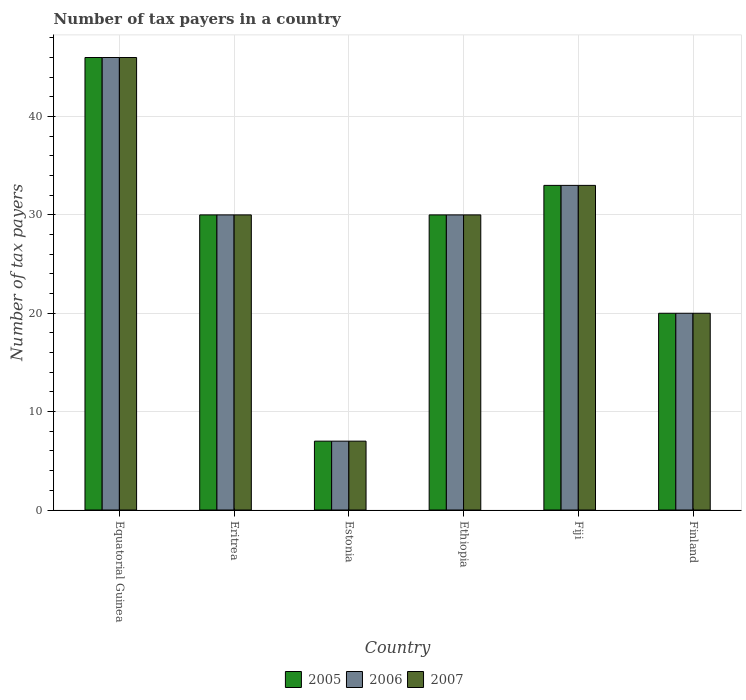How many bars are there on the 2nd tick from the left?
Provide a succinct answer. 3. How many bars are there on the 3rd tick from the right?
Your answer should be compact. 3. What is the label of the 4th group of bars from the left?
Offer a terse response. Ethiopia. In which country was the number of tax payers in in 2007 maximum?
Offer a very short reply. Equatorial Guinea. In which country was the number of tax payers in in 2007 minimum?
Make the answer very short. Estonia. What is the total number of tax payers in in 2005 in the graph?
Provide a succinct answer. 166. What is the difference between the number of tax payers in in 2005 in Eritrea and that in Estonia?
Make the answer very short. 23. What is the difference between the number of tax payers in in 2007 in Eritrea and the number of tax payers in in 2006 in Estonia?
Give a very brief answer. 23. What is the average number of tax payers in in 2007 per country?
Provide a short and direct response. 27.67. What is the difference between the number of tax payers in of/in 2005 and number of tax payers in of/in 2006 in Fiji?
Offer a very short reply. 0. Is the difference between the number of tax payers in in 2005 in Estonia and Fiji greater than the difference between the number of tax payers in in 2006 in Estonia and Fiji?
Provide a short and direct response. No. What is the difference between the highest and the lowest number of tax payers in in 2005?
Your answer should be very brief. 39. In how many countries, is the number of tax payers in in 2005 greater than the average number of tax payers in in 2005 taken over all countries?
Your answer should be compact. 4. How many bars are there?
Keep it short and to the point. 18. How many countries are there in the graph?
Your answer should be very brief. 6. What is the difference between two consecutive major ticks on the Y-axis?
Give a very brief answer. 10. Are the values on the major ticks of Y-axis written in scientific E-notation?
Provide a succinct answer. No. How many legend labels are there?
Give a very brief answer. 3. What is the title of the graph?
Offer a very short reply. Number of tax payers in a country. What is the label or title of the Y-axis?
Offer a terse response. Number of tax payers. What is the Number of tax payers in 2006 in Equatorial Guinea?
Keep it short and to the point. 46. What is the Number of tax payers of 2007 in Equatorial Guinea?
Provide a succinct answer. 46. What is the Number of tax payers in 2005 in Estonia?
Ensure brevity in your answer.  7. What is the Number of tax payers in 2005 in Ethiopia?
Offer a very short reply. 30. What is the Number of tax payers in 2005 in Finland?
Ensure brevity in your answer.  20. What is the Number of tax payers of 2006 in Finland?
Offer a very short reply. 20. What is the Number of tax payers of 2007 in Finland?
Offer a terse response. 20. Across all countries, what is the maximum Number of tax payers in 2005?
Provide a short and direct response. 46. Across all countries, what is the maximum Number of tax payers in 2007?
Offer a very short reply. 46. What is the total Number of tax payers of 2005 in the graph?
Keep it short and to the point. 166. What is the total Number of tax payers in 2006 in the graph?
Provide a short and direct response. 166. What is the total Number of tax payers of 2007 in the graph?
Provide a short and direct response. 166. What is the difference between the Number of tax payers in 2006 in Equatorial Guinea and that in Eritrea?
Offer a very short reply. 16. What is the difference between the Number of tax payers in 2007 in Equatorial Guinea and that in Eritrea?
Give a very brief answer. 16. What is the difference between the Number of tax payers of 2006 in Equatorial Guinea and that in Estonia?
Provide a short and direct response. 39. What is the difference between the Number of tax payers of 2007 in Equatorial Guinea and that in Estonia?
Ensure brevity in your answer.  39. What is the difference between the Number of tax payers in 2007 in Equatorial Guinea and that in Ethiopia?
Your answer should be compact. 16. What is the difference between the Number of tax payers in 2006 in Equatorial Guinea and that in Fiji?
Offer a very short reply. 13. What is the difference between the Number of tax payers in 2006 in Equatorial Guinea and that in Finland?
Offer a very short reply. 26. What is the difference between the Number of tax payers in 2007 in Equatorial Guinea and that in Finland?
Your response must be concise. 26. What is the difference between the Number of tax payers in 2005 in Eritrea and that in Estonia?
Your answer should be very brief. 23. What is the difference between the Number of tax payers in 2006 in Eritrea and that in Estonia?
Your response must be concise. 23. What is the difference between the Number of tax payers in 2005 in Eritrea and that in Ethiopia?
Make the answer very short. 0. What is the difference between the Number of tax payers in 2006 in Eritrea and that in Ethiopia?
Offer a very short reply. 0. What is the difference between the Number of tax payers in 2007 in Eritrea and that in Ethiopia?
Offer a very short reply. 0. What is the difference between the Number of tax payers in 2006 in Eritrea and that in Fiji?
Make the answer very short. -3. What is the difference between the Number of tax payers in 2005 in Eritrea and that in Finland?
Your answer should be compact. 10. What is the difference between the Number of tax payers in 2006 in Eritrea and that in Finland?
Offer a very short reply. 10. What is the difference between the Number of tax payers in 2005 in Estonia and that in Ethiopia?
Your answer should be compact. -23. What is the difference between the Number of tax payers of 2006 in Estonia and that in Ethiopia?
Give a very brief answer. -23. What is the difference between the Number of tax payers of 2005 in Estonia and that in Fiji?
Provide a succinct answer. -26. What is the difference between the Number of tax payers in 2007 in Estonia and that in Fiji?
Ensure brevity in your answer.  -26. What is the difference between the Number of tax payers of 2005 in Estonia and that in Finland?
Your answer should be compact. -13. What is the difference between the Number of tax payers of 2005 in Ethiopia and that in Fiji?
Your answer should be very brief. -3. What is the difference between the Number of tax payers of 2006 in Ethiopia and that in Fiji?
Provide a short and direct response. -3. What is the difference between the Number of tax payers of 2007 in Ethiopia and that in Fiji?
Make the answer very short. -3. What is the difference between the Number of tax payers of 2005 in Ethiopia and that in Finland?
Ensure brevity in your answer.  10. What is the difference between the Number of tax payers in 2006 in Ethiopia and that in Finland?
Offer a terse response. 10. What is the difference between the Number of tax payers of 2007 in Ethiopia and that in Finland?
Ensure brevity in your answer.  10. What is the difference between the Number of tax payers of 2006 in Fiji and that in Finland?
Provide a succinct answer. 13. What is the difference between the Number of tax payers of 2006 in Equatorial Guinea and the Number of tax payers of 2007 in Eritrea?
Make the answer very short. 16. What is the difference between the Number of tax payers in 2005 in Equatorial Guinea and the Number of tax payers in 2006 in Estonia?
Ensure brevity in your answer.  39. What is the difference between the Number of tax payers in 2005 in Equatorial Guinea and the Number of tax payers in 2006 in Ethiopia?
Make the answer very short. 16. What is the difference between the Number of tax payers of 2005 in Equatorial Guinea and the Number of tax payers of 2007 in Fiji?
Offer a very short reply. 13. What is the difference between the Number of tax payers of 2005 in Equatorial Guinea and the Number of tax payers of 2006 in Finland?
Keep it short and to the point. 26. What is the difference between the Number of tax payers in 2006 in Equatorial Guinea and the Number of tax payers in 2007 in Finland?
Provide a succinct answer. 26. What is the difference between the Number of tax payers in 2005 in Eritrea and the Number of tax payers in 2007 in Estonia?
Provide a succinct answer. 23. What is the difference between the Number of tax payers of 2005 in Eritrea and the Number of tax payers of 2006 in Ethiopia?
Provide a succinct answer. 0. What is the difference between the Number of tax payers in 2006 in Eritrea and the Number of tax payers in 2007 in Ethiopia?
Your answer should be very brief. 0. What is the difference between the Number of tax payers in 2005 in Eritrea and the Number of tax payers in 2006 in Fiji?
Make the answer very short. -3. What is the difference between the Number of tax payers in 2005 in Eritrea and the Number of tax payers in 2007 in Fiji?
Provide a short and direct response. -3. What is the difference between the Number of tax payers in 2006 in Eritrea and the Number of tax payers in 2007 in Fiji?
Provide a short and direct response. -3. What is the difference between the Number of tax payers in 2006 in Eritrea and the Number of tax payers in 2007 in Finland?
Ensure brevity in your answer.  10. What is the difference between the Number of tax payers in 2005 in Estonia and the Number of tax payers in 2006 in Fiji?
Your response must be concise. -26. What is the difference between the Number of tax payers in 2005 in Estonia and the Number of tax payers in 2007 in Fiji?
Provide a succinct answer. -26. What is the difference between the Number of tax payers of 2006 in Estonia and the Number of tax payers of 2007 in Fiji?
Your answer should be compact. -26. What is the difference between the Number of tax payers of 2005 in Estonia and the Number of tax payers of 2006 in Finland?
Your answer should be compact. -13. What is the difference between the Number of tax payers in 2005 in Estonia and the Number of tax payers in 2007 in Finland?
Your answer should be very brief. -13. What is the difference between the Number of tax payers of 2005 in Ethiopia and the Number of tax payers of 2006 in Fiji?
Offer a terse response. -3. What is the difference between the Number of tax payers of 2005 in Ethiopia and the Number of tax payers of 2007 in Fiji?
Provide a short and direct response. -3. What is the difference between the Number of tax payers in 2005 in Ethiopia and the Number of tax payers in 2006 in Finland?
Ensure brevity in your answer.  10. What is the difference between the Number of tax payers of 2005 in Ethiopia and the Number of tax payers of 2007 in Finland?
Keep it short and to the point. 10. What is the difference between the Number of tax payers in 2006 in Ethiopia and the Number of tax payers in 2007 in Finland?
Provide a short and direct response. 10. What is the difference between the Number of tax payers in 2005 in Fiji and the Number of tax payers in 2007 in Finland?
Provide a short and direct response. 13. What is the average Number of tax payers in 2005 per country?
Your answer should be very brief. 27.67. What is the average Number of tax payers in 2006 per country?
Make the answer very short. 27.67. What is the average Number of tax payers in 2007 per country?
Ensure brevity in your answer.  27.67. What is the difference between the Number of tax payers in 2005 and Number of tax payers in 2006 in Equatorial Guinea?
Your answer should be very brief. 0. What is the difference between the Number of tax payers in 2006 and Number of tax payers in 2007 in Equatorial Guinea?
Make the answer very short. 0. What is the difference between the Number of tax payers in 2006 and Number of tax payers in 2007 in Eritrea?
Provide a short and direct response. 0. What is the difference between the Number of tax payers in 2005 and Number of tax payers in 2006 in Estonia?
Offer a very short reply. 0. What is the difference between the Number of tax payers of 2005 and Number of tax payers of 2007 in Ethiopia?
Your response must be concise. 0. What is the difference between the Number of tax payers in 2005 and Number of tax payers in 2006 in Finland?
Your response must be concise. 0. What is the difference between the Number of tax payers in 2005 and Number of tax payers in 2007 in Finland?
Your answer should be compact. 0. What is the difference between the Number of tax payers of 2006 and Number of tax payers of 2007 in Finland?
Your answer should be compact. 0. What is the ratio of the Number of tax payers in 2005 in Equatorial Guinea to that in Eritrea?
Offer a very short reply. 1.53. What is the ratio of the Number of tax payers of 2006 in Equatorial Guinea to that in Eritrea?
Keep it short and to the point. 1.53. What is the ratio of the Number of tax payers in 2007 in Equatorial Guinea to that in Eritrea?
Ensure brevity in your answer.  1.53. What is the ratio of the Number of tax payers in 2005 in Equatorial Guinea to that in Estonia?
Your answer should be very brief. 6.57. What is the ratio of the Number of tax payers in 2006 in Equatorial Guinea to that in Estonia?
Your response must be concise. 6.57. What is the ratio of the Number of tax payers of 2007 in Equatorial Guinea to that in Estonia?
Your answer should be compact. 6.57. What is the ratio of the Number of tax payers in 2005 in Equatorial Guinea to that in Ethiopia?
Your response must be concise. 1.53. What is the ratio of the Number of tax payers in 2006 in Equatorial Guinea to that in Ethiopia?
Keep it short and to the point. 1.53. What is the ratio of the Number of tax payers in 2007 in Equatorial Guinea to that in Ethiopia?
Offer a terse response. 1.53. What is the ratio of the Number of tax payers of 2005 in Equatorial Guinea to that in Fiji?
Your answer should be compact. 1.39. What is the ratio of the Number of tax payers of 2006 in Equatorial Guinea to that in Fiji?
Ensure brevity in your answer.  1.39. What is the ratio of the Number of tax payers of 2007 in Equatorial Guinea to that in Fiji?
Provide a succinct answer. 1.39. What is the ratio of the Number of tax payers in 2005 in Equatorial Guinea to that in Finland?
Make the answer very short. 2.3. What is the ratio of the Number of tax payers in 2006 in Equatorial Guinea to that in Finland?
Your response must be concise. 2.3. What is the ratio of the Number of tax payers in 2005 in Eritrea to that in Estonia?
Provide a short and direct response. 4.29. What is the ratio of the Number of tax payers of 2006 in Eritrea to that in Estonia?
Keep it short and to the point. 4.29. What is the ratio of the Number of tax payers in 2007 in Eritrea to that in Estonia?
Offer a very short reply. 4.29. What is the ratio of the Number of tax payers in 2006 in Eritrea to that in Ethiopia?
Your answer should be very brief. 1. What is the ratio of the Number of tax payers of 2007 in Eritrea to that in Ethiopia?
Your response must be concise. 1. What is the ratio of the Number of tax payers in 2005 in Eritrea to that in Fiji?
Your answer should be very brief. 0.91. What is the ratio of the Number of tax payers of 2006 in Eritrea to that in Fiji?
Make the answer very short. 0.91. What is the ratio of the Number of tax payers of 2007 in Eritrea to that in Fiji?
Provide a short and direct response. 0.91. What is the ratio of the Number of tax payers in 2005 in Eritrea to that in Finland?
Offer a very short reply. 1.5. What is the ratio of the Number of tax payers in 2005 in Estonia to that in Ethiopia?
Provide a succinct answer. 0.23. What is the ratio of the Number of tax payers of 2006 in Estonia to that in Ethiopia?
Provide a succinct answer. 0.23. What is the ratio of the Number of tax payers of 2007 in Estonia to that in Ethiopia?
Give a very brief answer. 0.23. What is the ratio of the Number of tax payers of 2005 in Estonia to that in Fiji?
Your answer should be compact. 0.21. What is the ratio of the Number of tax payers in 2006 in Estonia to that in Fiji?
Give a very brief answer. 0.21. What is the ratio of the Number of tax payers in 2007 in Estonia to that in Fiji?
Offer a very short reply. 0.21. What is the ratio of the Number of tax payers of 2006 in Estonia to that in Finland?
Provide a succinct answer. 0.35. What is the ratio of the Number of tax payers in 2007 in Estonia to that in Finland?
Make the answer very short. 0.35. What is the ratio of the Number of tax payers of 2007 in Ethiopia to that in Fiji?
Offer a terse response. 0.91. What is the ratio of the Number of tax payers in 2006 in Ethiopia to that in Finland?
Your answer should be very brief. 1.5. What is the ratio of the Number of tax payers of 2005 in Fiji to that in Finland?
Make the answer very short. 1.65. What is the ratio of the Number of tax payers in 2006 in Fiji to that in Finland?
Offer a very short reply. 1.65. What is the ratio of the Number of tax payers of 2007 in Fiji to that in Finland?
Keep it short and to the point. 1.65. What is the difference between the highest and the lowest Number of tax payers of 2005?
Provide a succinct answer. 39. What is the difference between the highest and the lowest Number of tax payers of 2006?
Keep it short and to the point. 39. What is the difference between the highest and the lowest Number of tax payers of 2007?
Offer a very short reply. 39. 